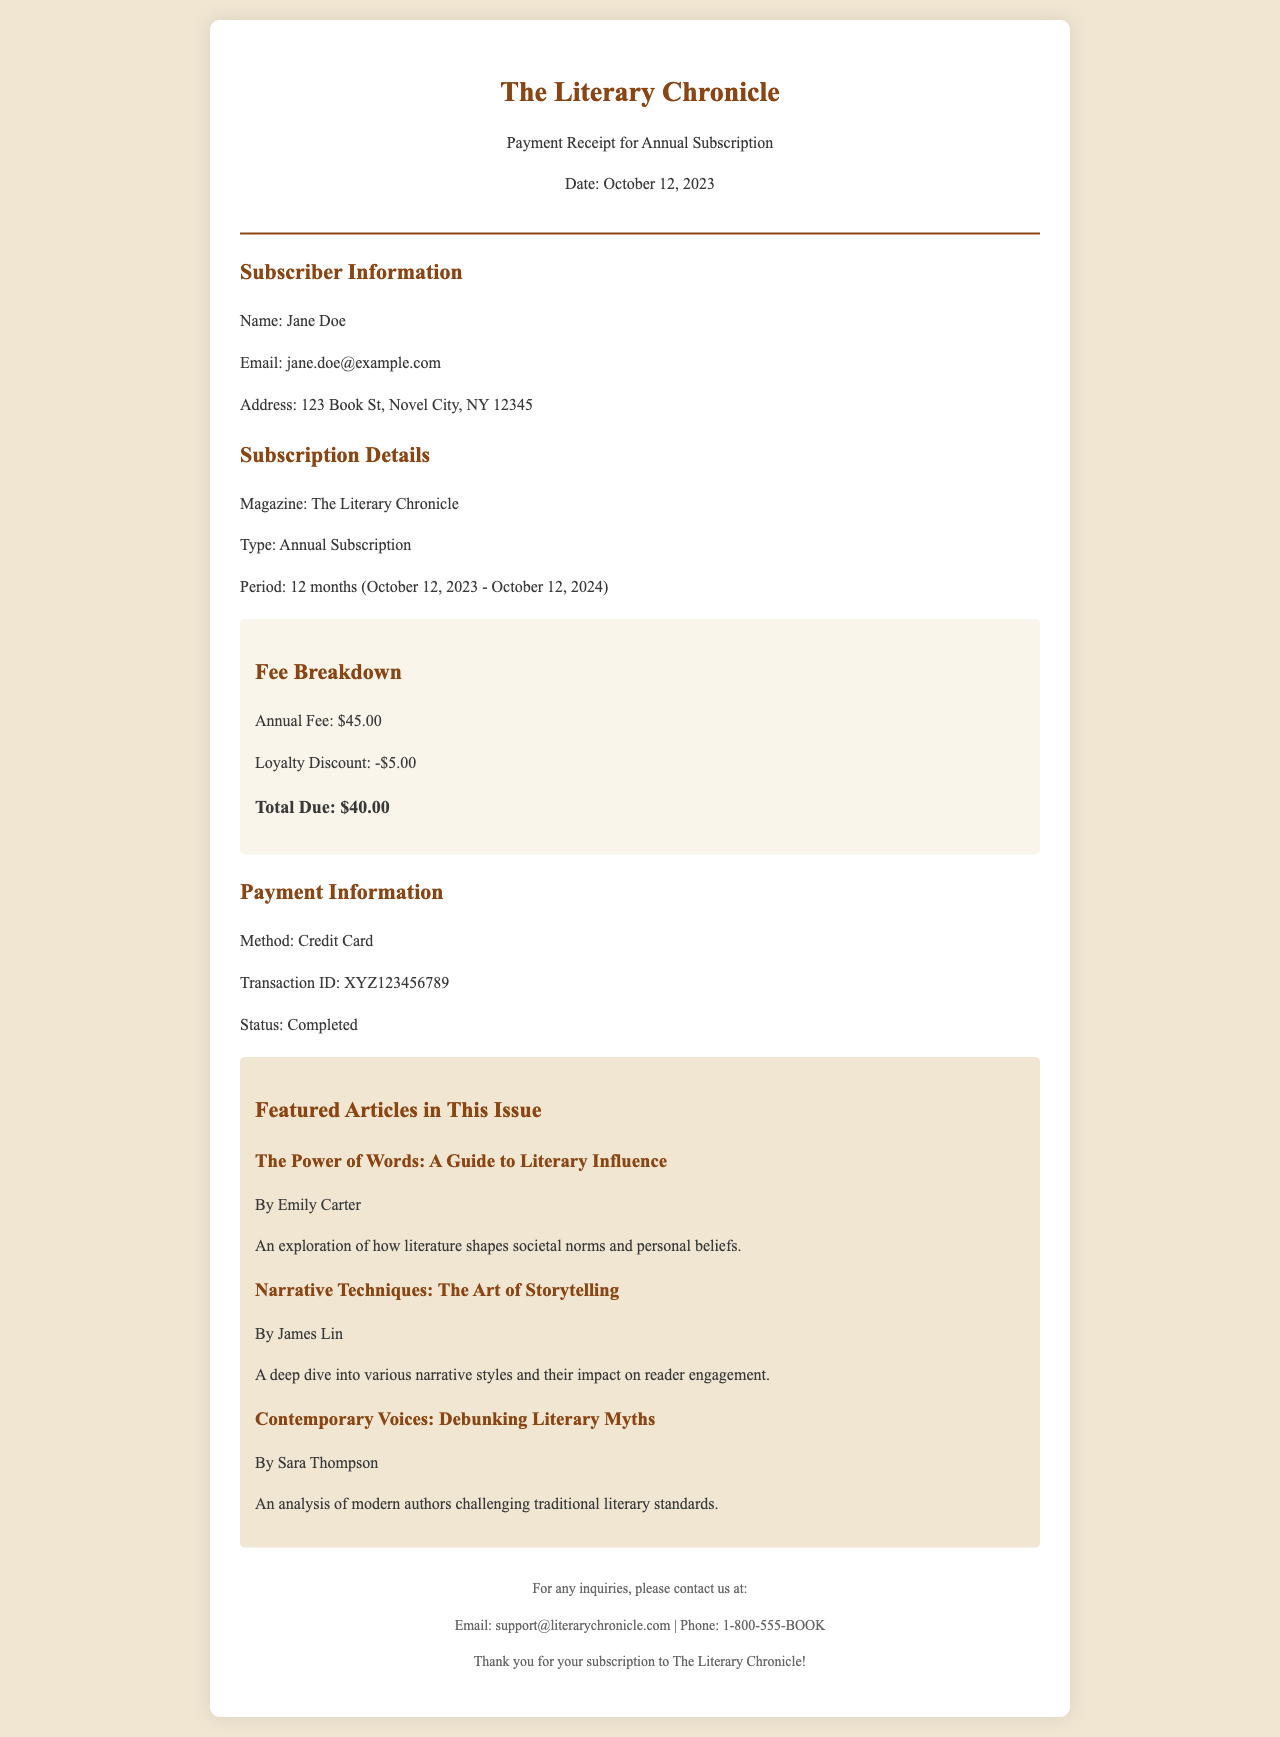What is the name of the subscriber? The subscriber's name is located in the subscriber information section.
Answer: Jane Doe What is the date of the payment receipt? The date is prominently displayed in the header section of the receipt.
Answer: October 12, 2023 What is the annual fee for the subscription? The annual fee is stated in the fee breakdown section.
Answer: $45.00 What discount is applied to the subscription? The loyalty discount is mentioned in the fee breakdown.
Answer: -$5.00 What is the total amount due? The total due can be found in the fee breakdown as the final amount.
Answer: $40.00 What method of payment was used? The method of payment is mentioned in the payment information section.
Answer: Credit Card How many featured articles are listed? The number can be counted in the featured articles section of the document.
Answer: 3 Who is the author of the article titled "The Power of Words: A Guide to Literary Influence"? The author’s name is provided below the article title.
Answer: Emily Carter What is the email contact for inquiries? This information is found in the footer of the document.
Answer: support@literarychronicle.com 